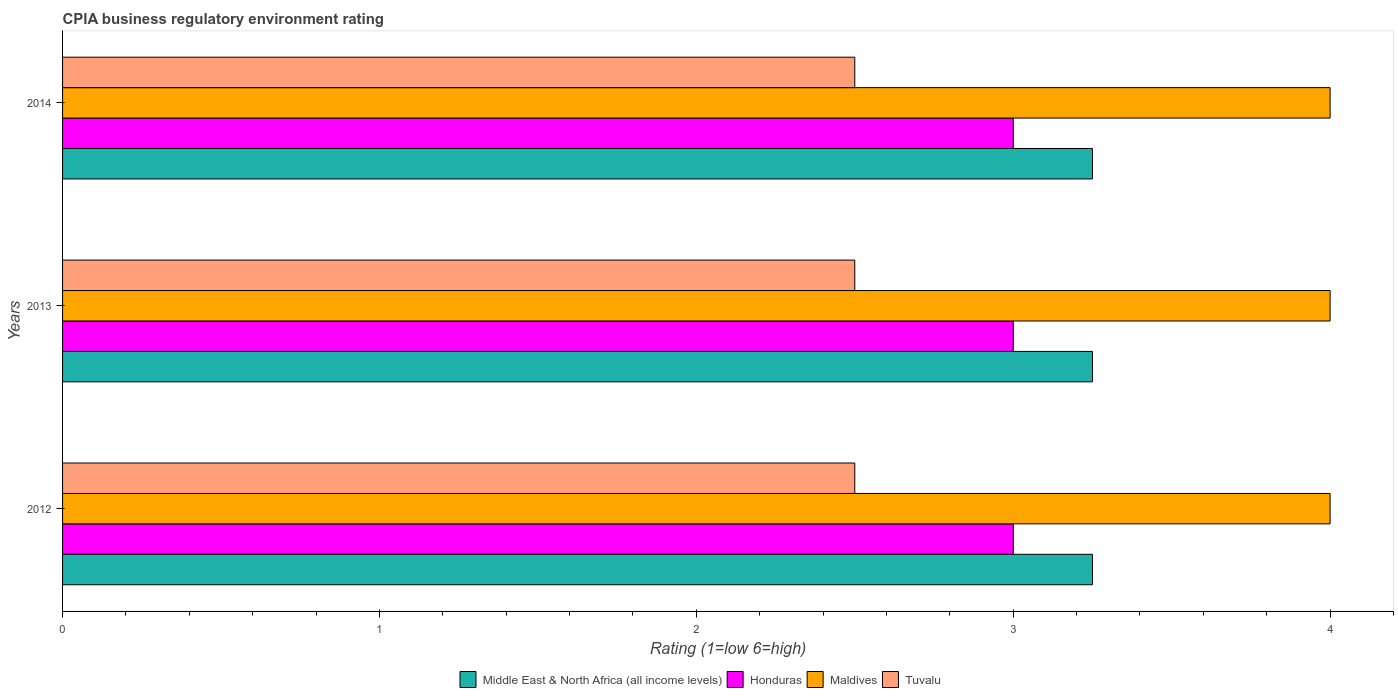How many different coloured bars are there?
Make the answer very short. 4. How many groups of bars are there?
Give a very brief answer. 3. How many bars are there on the 3rd tick from the top?
Provide a short and direct response. 4. How many bars are there on the 1st tick from the bottom?
Provide a short and direct response. 4. In how many cases, is the number of bars for a given year not equal to the number of legend labels?
Keep it short and to the point. 0. Across all years, what is the maximum CPIA rating in Tuvalu?
Offer a terse response. 2.5. Across all years, what is the minimum CPIA rating in Honduras?
Provide a short and direct response. 3. What is the total CPIA rating in Maldives in the graph?
Make the answer very short. 12. What is the difference between the CPIA rating in Maldives in 2012 and that in 2014?
Provide a short and direct response. 0. What is the difference between the CPIA rating in Middle East & North Africa (all income levels) in 2014 and the CPIA rating in Maldives in 2012?
Your answer should be compact. -0.75. In the year 2012, what is the difference between the CPIA rating in Tuvalu and CPIA rating in Middle East & North Africa (all income levels)?
Ensure brevity in your answer.  -0.75. Is the difference between the CPIA rating in Tuvalu in 2012 and 2014 greater than the difference between the CPIA rating in Middle East & North Africa (all income levels) in 2012 and 2014?
Provide a short and direct response. No. What is the difference between the highest and the second highest CPIA rating in Maldives?
Your answer should be compact. 0. What is the difference between the highest and the lowest CPIA rating in Tuvalu?
Give a very brief answer. 0. Is the sum of the CPIA rating in Maldives in 2012 and 2013 greater than the maximum CPIA rating in Honduras across all years?
Provide a succinct answer. Yes. Is it the case that in every year, the sum of the CPIA rating in Maldives and CPIA rating in Middle East & North Africa (all income levels) is greater than the sum of CPIA rating in Tuvalu and CPIA rating in Honduras?
Offer a very short reply. Yes. What does the 4th bar from the top in 2012 represents?
Your response must be concise. Middle East & North Africa (all income levels). What does the 3rd bar from the bottom in 2013 represents?
Give a very brief answer. Maldives. How many years are there in the graph?
Give a very brief answer. 3. Are the values on the major ticks of X-axis written in scientific E-notation?
Your answer should be very brief. No. Does the graph contain any zero values?
Provide a short and direct response. No. How many legend labels are there?
Provide a short and direct response. 4. How are the legend labels stacked?
Ensure brevity in your answer.  Horizontal. What is the title of the graph?
Make the answer very short. CPIA business regulatory environment rating. What is the label or title of the X-axis?
Provide a succinct answer. Rating (1=low 6=high). What is the Rating (1=low 6=high) of Honduras in 2012?
Your answer should be very brief. 3. What is the Rating (1=low 6=high) in Middle East & North Africa (all income levels) in 2013?
Provide a succinct answer. 3.25. What is the Rating (1=low 6=high) of Maldives in 2013?
Provide a short and direct response. 4. What is the Rating (1=low 6=high) in Middle East & North Africa (all income levels) in 2014?
Provide a short and direct response. 3.25. What is the Rating (1=low 6=high) of Honduras in 2014?
Give a very brief answer. 3. What is the Rating (1=low 6=high) of Maldives in 2014?
Keep it short and to the point. 4. What is the Rating (1=low 6=high) of Tuvalu in 2014?
Give a very brief answer. 2.5. Across all years, what is the maximum Rating (1=low 6=high) of Middle East & North Africa (all income levels)?
Your answer should be very brief. 3.25. What is the total Rating (1=low 6=high) in Middle East & North Africa (all income levels) in the graph?
Give a very brief answer. 9.75. What is the total Rating (1=low 6=high) of Tuvalu in the graph?
Provide a succinct answer. 7.5. What is the difference between the Rating (1=low 6=high) in Middle East & North Africa (all income levels) in 2012 and that in 2014?
Provide a succinct answer. 0. What is the difference between the Rating (1=low 6=high) in Tuvalu in 2012 and that in 2014?
Your answer should be compact. 0. What is the difference between the Rating (1=low 6=high) of Middle East & North Africa (all income levels) in 2013 and that in 2014?
Your response must be concise. 0. What is the difference between the Rating (1=low 6=high) in Tuvalu in 2013 and that in 2014?
Your answer should be compact. 0. What is the difference between the Rating (1=low 6=high) in Middle East & North Africa (all income levels) in 2012 and the Rating (1=low 6=high) in Maldives in 2013?
Provide a short and direct response. -0.75. What is the difference between the Rating (1=low 6=high) in Honduras in 2012 and the Rating (1=low 6=high) in Maldives in 2013?
Your answer should be very brief. -1. What is the difference between the Rating (1=low 6=high) of Middle East & North Africa (all income levels) in 2012 and the Rating (1=low 6=high) of Honduras in 2014?
Ensure brevity in your answer.  0.25. What is the difference between the Rating (1=low 6=high) of Middle East & North Africa (all income levels) in 2012 and the Rating (1=low 6=high) of Maldives in 2014?
Ensure brevity in your answer.  -0.75. What is the difference between the Rating (1=low 6=high) of Middle East & North Africa (all income levels) in 2012 and the Rating (1=low 6=high) of Tuvalu in 2014?
Keep it short and to the point. 0.75. What is the difference between the Rating (1=low 6=high) in Middle East & North Africa (all income levels) in 2013 and the Rating (1=low 6=high) in Maldives in 2014?
Your answer should be very brief. -0.75. What is the difference between the Rating (1=low 6=high) in Honduras in 2013 and the Rating (1=low 6=high) in Tuvalu in 2014?
Provide a short and direct response. 0.5. What is the average Rating (1=low 6=high) in Honduras per year?
Your answer should be very brief. 3. What is the average Rating (1=low 6=high) of Maldives per year?
Make the answer very short. 4. What is the average Rating (1=low 6=high) of Tuvalu per year?
Your answer should be very brief. 2.5. In the year 2012, what is the difference between the Rating (1=low 6=high) in Middle East & North Africa (all income levels) and Rating (1=low 6=high) in Honduras?
Your response must be concise. 0.25. In the year 2012, what is the difference between the Rating (1=low 6=high) in Middle East & North Africa (all income levels) and Rating (1=low 6=high) in Maldives?
Offer a very short reply. -0.75. In the year 2012, what is the difference between the Rating (1=low 6=high) of Maldives and Rating (1=low 6=high) of Tuvalu?
Give a very brief answer. 1.5. In the year 2013, what is the difference between the Rating (1=low 6=high) in Middle East & North Africa (all income levels) and Rating (1=low 6=high) in Honduras?
Offer a terse response. 0.25. In the year 2013, what is the difference between the Rating (1=low 6=high) of Middle East & North Africa (all income levels) and Rating (1=low 6=high) of Maldives?
Keep it short and to the point. -0.75. In the year 2013, what is the difference between the Rating (1=low 6=high) of Middle East & North Africa (all income levels) and Rating (1=low 6=high) of Tuvalu?
Your answer should be compact. 0.75. In the year 2013, what is the difference between the Rating (1=low 6=high) of Honduras and Rating (1=low 6=high) of Tuvalu?
Keep it short and to the point. 0.5. In the year 2013, what is the difference between the Rating (1=low 6=high) of Maldives and Rating (1=low 6=high) of Tuvalu?
Give a very brief answer. 1.5. In the year 2014, what is the difference between the Rating (1=low 6=high) in Middle East & North Africa (all income levels) and Rating (1=low 6=high) in Honduras?
Keep it short and to the point. 0.25. In the year 2014, what is the difference between the Rating (1=low 6=high) in Middle East & North Africa (all income levels) and Rating (1=low 6=high) in Maldives?
Your response must be concise. -0.75. In the year 2014, what is the difference between the Rating (1=low 6=high) of Middle East & North Africa (all income levels) and Rating (1=low 6=high) of Tuvalu?
Offer a terse response. 0.75. In the year 2014, what is the difference between the Rating (1=low 6=high) in Honduras and Rating (1=low 6=high) in Maldives?
Provide a succinct answer. -1. In the year 2014, what is the difference between the Rating (1=low 6=high) in Maldives and Rating (1=low 6=high) in Tuvalu?
Offer a very short reply. 1.5. What is the ratio of the Rating (1=low 6=high) of Maldives in 2012 to that in 2013?
Offer a very short reply. 1. What is the ratio of the Rating (1=low 6=high) of Tuvalu in 2012 to that in 2013?
Your answer should be very brief. 1. What is the ratio of the Rating (1=low 6=high) in Honduras in 2012 to that in 2014?
Your answer should be compact. 1. What is the ratio of the Rating (1=low 6=high) of Tuvalu in 2012 to that in 2014?
Keep it short and to the point. 1. What is the ratio of the Rating (1=low 6=high) in Middle East & North Africa (all income levels) in 2013 to that in 2014?
Provide a succinct answer. 1. What is the ratio of the Rating (1=low 6=high) of Honduras in 2013 to that in 2014?
Offer a very short reply. 1. What is the ratio of the Rating (1=low 6=high) of Maldives in 2013 to that in 2014?
Provide a succinct answer. 1. What is the difference between the highest and the second highest Rating (1=low 6=high) in Honduras?
Provide a short and direct response. 0. What is the difference between the highest and the second highest Rating (1=low 6=high) of Tuvalu?
Keep it short and to the point. 0. What is the difference between the highest and the lowest Rating (1=low 6=high) of Honduras?
Provide a succinct answer. 0. 